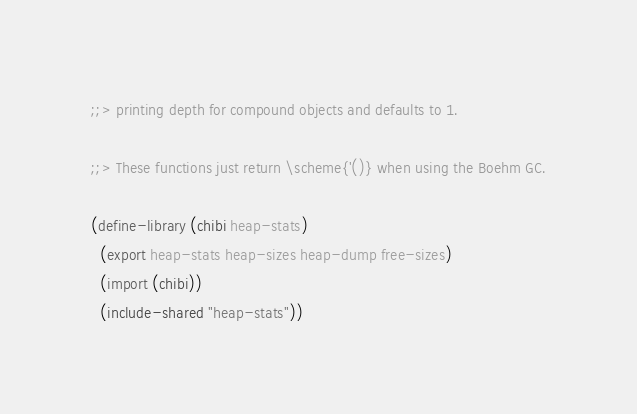<code> <loc_0><loc_0><loc_500><loc_500><_Scheme_>;;> printing depth for compound objects and defaults to 1.

;;> These functions just return \scheme{'()} when using the Boehm GC.

(define-library (chibi heap-stats)
  (export heap-stats heap-sizes heap-dump free-sizes)
  (import (chibi))
  (include-shared "heap-stats"))
</code> 